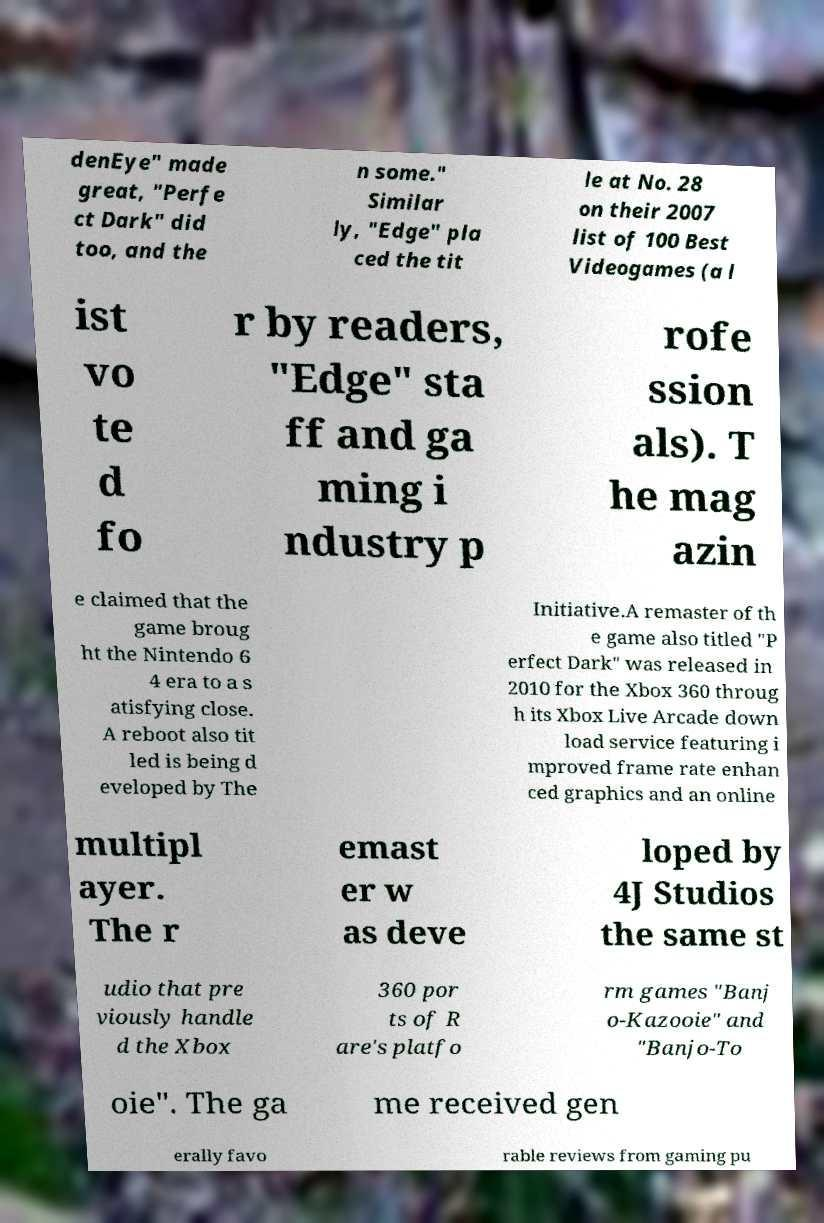What messages or text are displayed in this image? I need them in a readable, typed format. denEye" made great, "Perfe ct Dark" did too, and the n some." Similar ly, "Edge" pla ced the tit le at No. 28 on their 2007 list of 100 Best Videogames (a l ist vo te d fo r by readers, "Edge" sta ff and ga ming i ndustry p rofe ssion als). T he mag azin e claimed that the game broug ht the Nintendo 6 4 era to a s atisfying close. A reboot also tit led is being d eveloped by The Initiative.A remaster of th e game also titled "P erfect Dark" was released in 2010 for the Xbox 360 throug h its Xbox Live Arcade down load service featuring i mproved frame rate enhan ced graphics and an online multipl ayer. The r emast er w as deve loped by 4J Studios the same st udio that pre viously handle d the Xbox 360 por ts of R are's platfo rm games "Banj o-Kazooie" and "Banjo-To oie". The ga me received gen erally favo rable reviews from gaming pu 